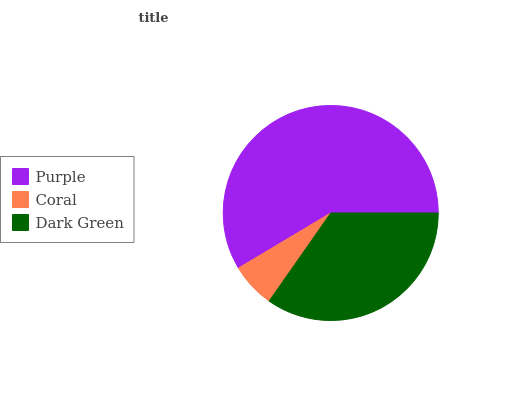Is Coral the minimum?
Answer yes or no. Yes. Is Purple the maximum?
Answer yes or no. Yes. Is Dark Green the minimum?
Answer yes or no. No. Is Dark Green the maximum?
Answer yes or no. No. Is Dark Green greater than Coral?
Answer yes or no. Yes. Is Coral less than Dark Green?
Answer yes or no. Yes. Is Coral greater than Dark Green?
Answer yes or no. No. Is Dark Green less than Coral?
Answer yes or no. No. Is Dark Green the high median?
Answer yes or no. Yes. Is Dark Green the low median?
Answer yes or no. Yes. Is Purple the high median?
Answer yes or no. No. Is Purple the low median?
Answer yes or no. No. 